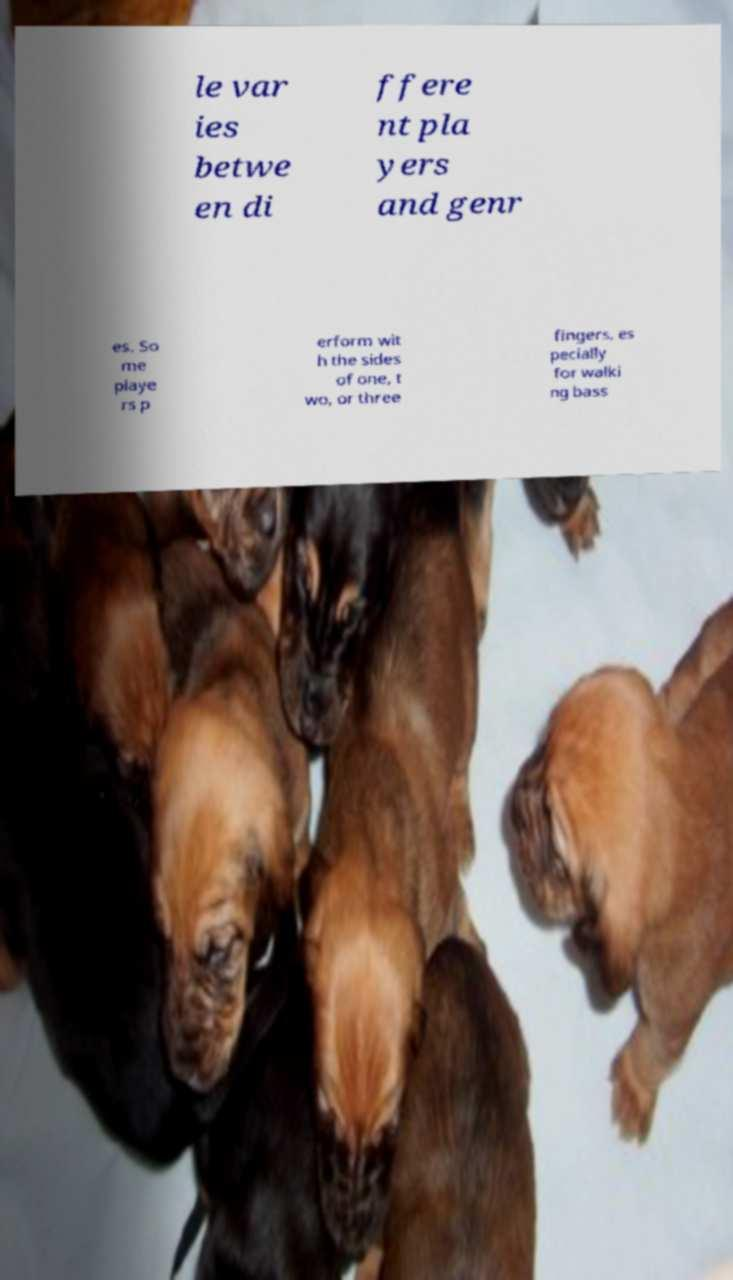Please read and relay the text visible in this image. What does it say? le var ies betwe en di ffere nt pla yers and genr es. So me playe rs p erform wit h the sides of one, t wo, or three fingers, es pecially for walki ng bass 